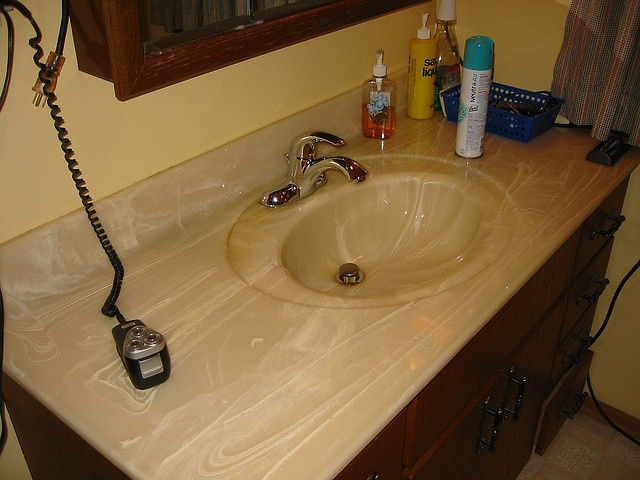Describe the objects in this image and their specific colors. I can see sink in black, olive, and tan tones, bottle in black, maroon, and gray tones, and bottle in black, maroon, and gray tones in this image. 